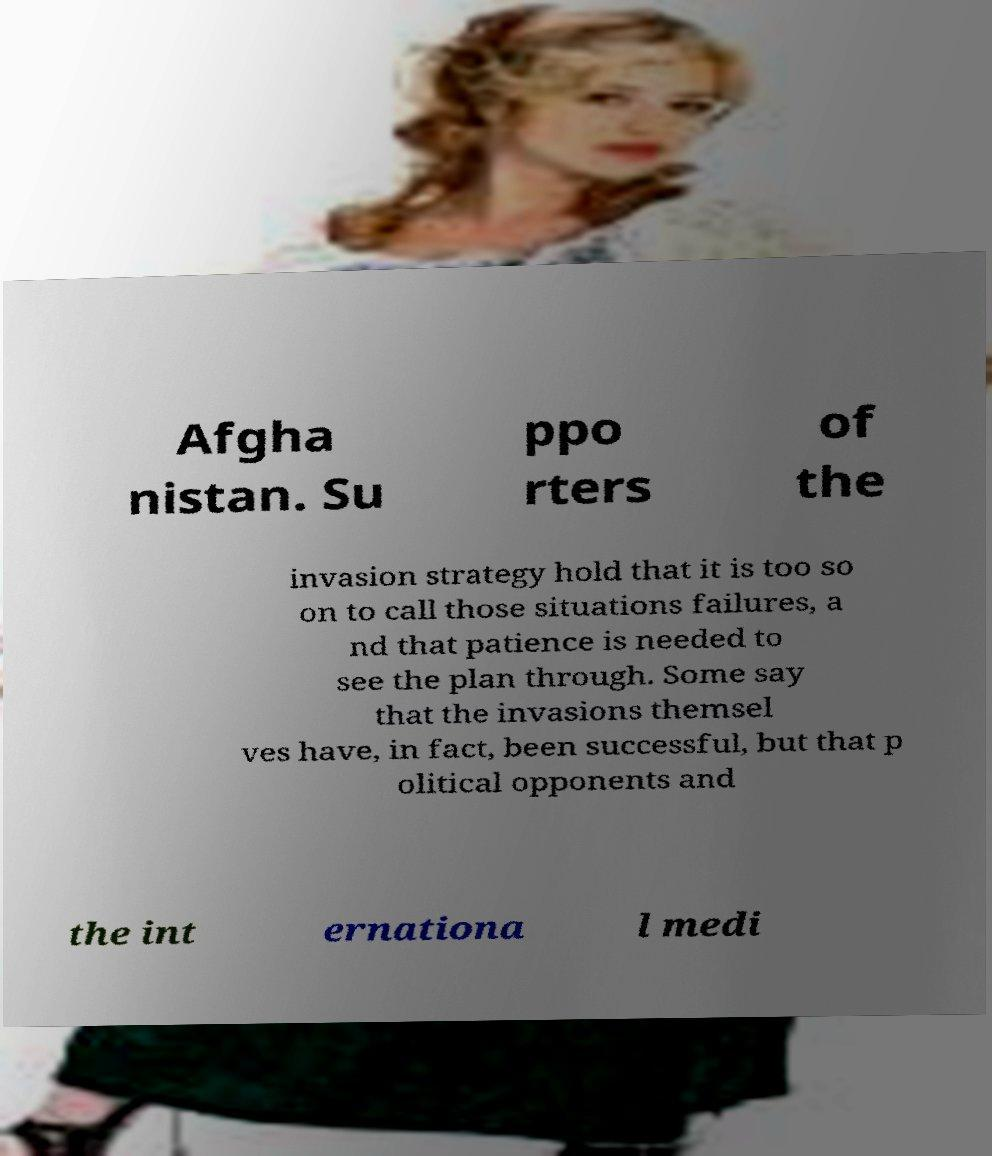Can you accurately transcribe the text from the provided image for me? Afgha nistan. Su ppo rters of the invasion strategy hold that it is too so on to call those situations failures, a nd that patience is needed to see the plan through. Some say that the invasions themsel ves have, in fact, been successful, but that p olitical opponents and the int ernationa l medi 